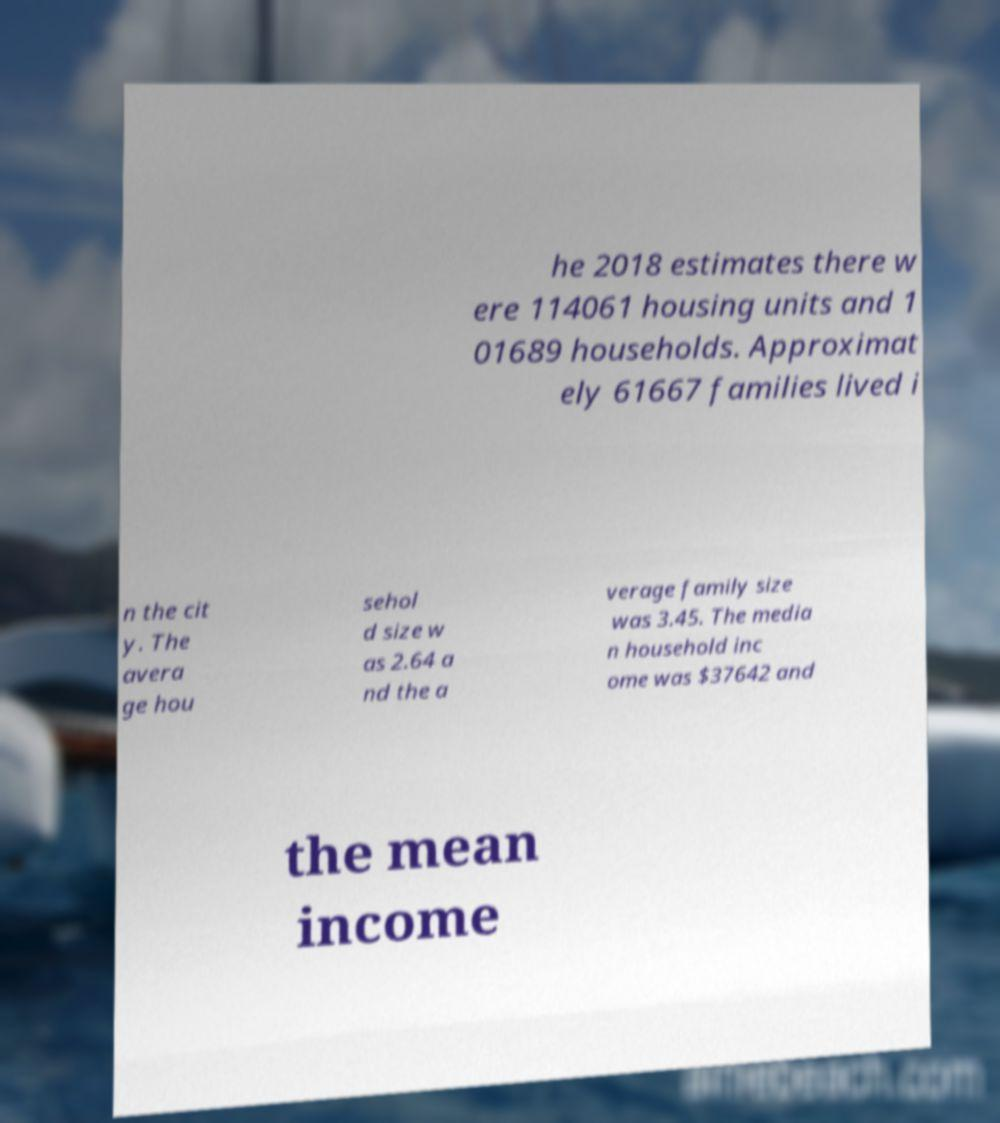Please identify and transcribe the text found in this image. he 2018 estimates there w ere 114061 housing units and 1 01689 households. Approximat ely 61667 families lived i n the cit y. The avera ge hou sehol d size w as 2.64 a nd the a verage family size was 3.45. The media n household inc ome was $37642 and the mean income 